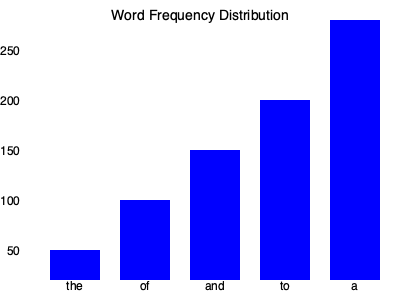Based on the word frequency distribution shown in the bar chart, which word appears to be the most frequent in the given text corpus, and approximately how many times does it occur? To answer this question, we need to analyze the bar chart representing the word frequency distribution:

1. The x-axis shows five common words: "the", "of", "and", "to", and "a".
2. The y-axis represents the frequency of occurrence, with intervals of 50 up to 250.
3. Each bar's height corresponds to the frequency of the word it represents.

Examining the bars:
- "the" has a frequency of about 50
- "of" has a frequency of about 100
- "and" has a frequency of about 150
- "to" has a frequency of about 200
- "a" has the tallest bar, reaching close to the 250 mark

Therefore, the word "a" appears to be the most frequent in the given text corpus, occurring approximately 250 times.

This distribution is typical of function words in English, which often follow Zipf's law. As a computational linguist, you would recognize that these high-frequency words are often stopwords in many NLP tasks but can be crucial in certain linguistic analyses.
Answer: "a", occurring approximately 250 times 